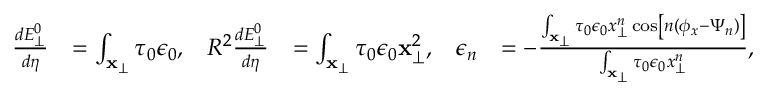Convert formula to latex. <formula><loc_0><loc_0><loc_500><loc_500>\begin{array} { r l r l r l } { \frac { d E _ { \perp } ^ { 0 } } { d \eta } } & { = \int _ { x _ { \perp } } \tau _ { 0 } \epsilon _ { 0 } , } & { R ^ { 2 } \frac { d E _ { \perp } ^ { 0 } } { d \eta } } & { = \int _ { x _ { \perp } } \tau _ { 0 } \epsilon _ { 0 } x _ { \perp } ^ { 2 } , } & { \epsilon _ { n } } & { = - \frac { \int _ { x _ { \perp } } \tau _ { 0 } \epsilon _ { 0 } x _ { \perp } ^ { n } \cos \left [ n ( \phi _ { x } - \Psi _ { n } ) \right ] } { \int _ { x _ { \perp } } \tau _ { 0 } \epsilon _ { 0 } x _ { \perp } ^ { n } } , } \end{array}</formula> 